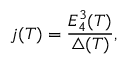Convert formula to latex. <formula><loc_0><loc_0><loc_500><loc_500>j ( T ) = \frac { E _ { 4 } ^ { 3 } ( T ) } { \triangle ( T ) } ,</formula> 